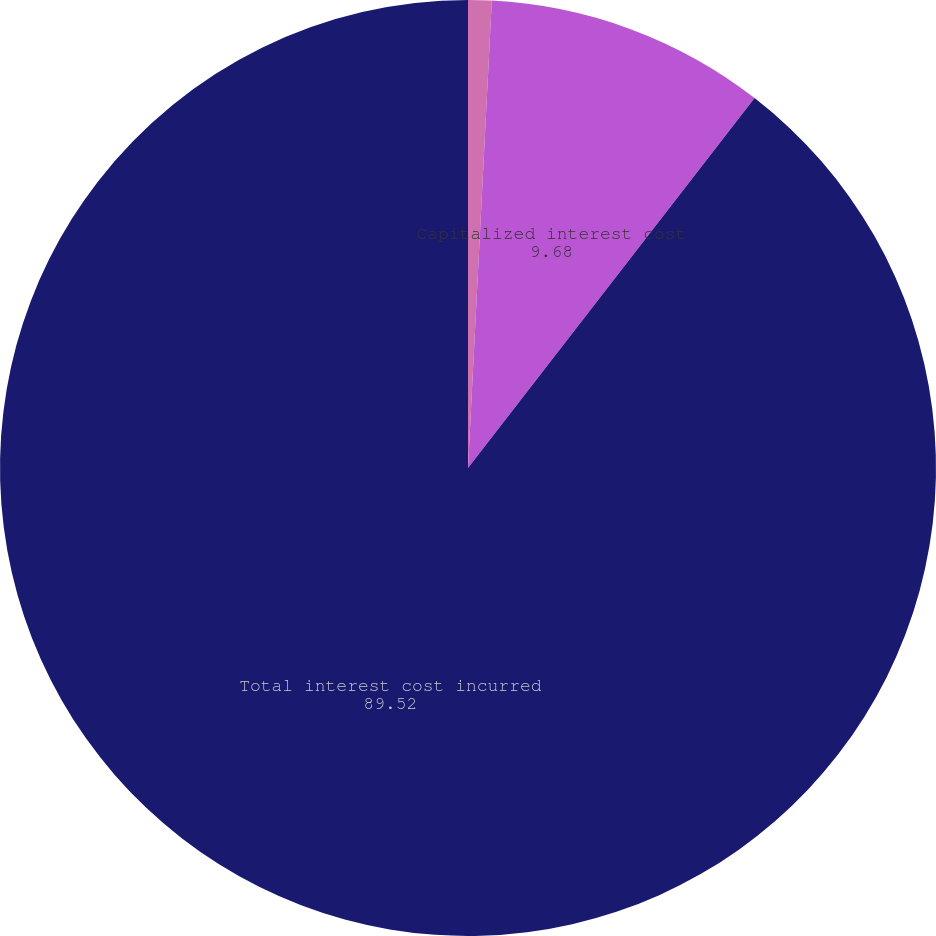Convert chart to OTSL. <chart><loc_0><loc_0><loc_500><loc_500><pie_chart><fcel>in thousands<fcel>Capitalized interest cost<fcel>Total interest cost incurred<nl><fcel>0.81%<fcel>9.68%<fcel>89.52%<nl></chart> 